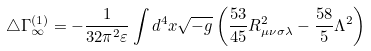Convert formula to latex. <formula><loc_0><loc_0><loc_500><loc_500>\triangle \Gamma ^ { ( 1 ) } _ { \infty } = - \frac { 1 } { 3 2 \pi ^ { 2 } \varepsilon } \int d ^ { 4 } x \sqrt { - g } \left ( \frac { 5 3 } { 4 5 } R _ { \mu \nu \sigma \lambda } ^ { 2 } - \frac { 5 8 } { 5 } \Lambda ^ { 2 } \right )</formula> 